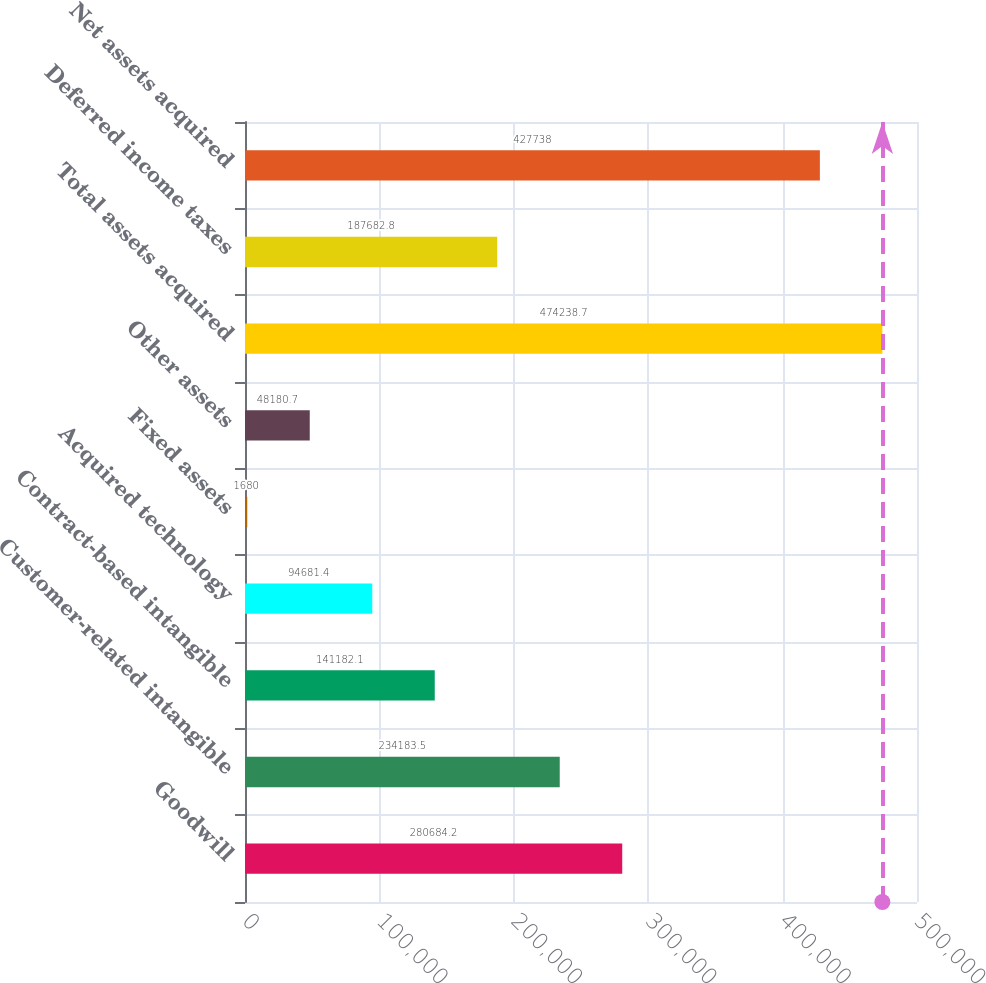Convert chart to OTSL. <chart><loc_0><loc_0><loc_500><loc_500><bar_chart><fcel>Goodwill<fcel>Customer-related intangible<fcel>Contract-based intangible<fcel>Acquired technology<fcel>Fixed assets<fcel>Other assets<fcel>Total assets acquired<fcel>Deferred income taxes<fcel>Net assets acquired<nl><fcel>280684<fcel>234184<fcel>141182<fcel>94681.4<fcel>1680<fcel>48180.7<fcel>474239<fcel>187683<fcel>427738<nl></chart> 